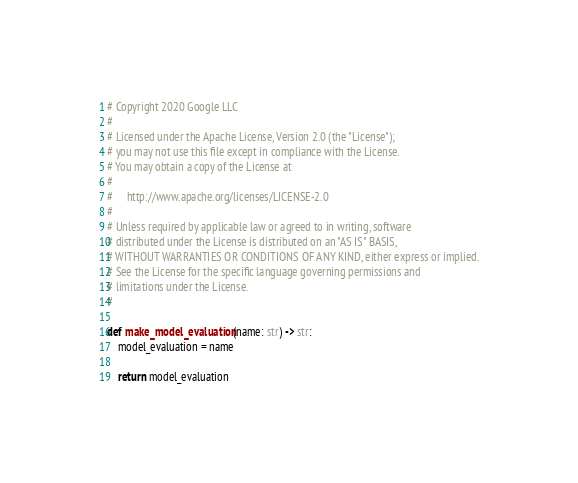<code> <loc_0><loc_0><loc_500><loc_500><_Python_># Copyright 2020 Google LLC
#
# Licensed under the Apache License, Version 2.0 (the "License");
# you may not use this file except in compliance with the License.
# You may obtain a copy of the License at
#
#     http://www.apache.org/licenses/LICENSE-2.0
#
# Unless required by applicable law or agreed to in writing, software
# distributed under the License is distributed on an "AS IS" BASIS,
# WITHOUT WARRANTIES OR CONDITIONS OF ANY KIND, either express or implied.
# See the License for the specific language governing permissions and
# limitations under the License.
#

def make_model_evaluation(name: str) -> str:
    model_evaluation = name

    return model_evaluation

</code> 